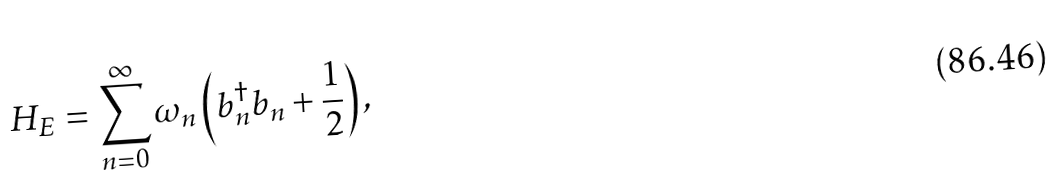<formula> <loc_0><loc_0><loc_500><loc_500>H _ { E } = \sum _ { n = 0 } ^ { \infty } \omega _ { n } \left ( b _ { n } ^ { \dagger } b _ { n } + \frac { 1 } { 2 } \right ) ,</formula> 